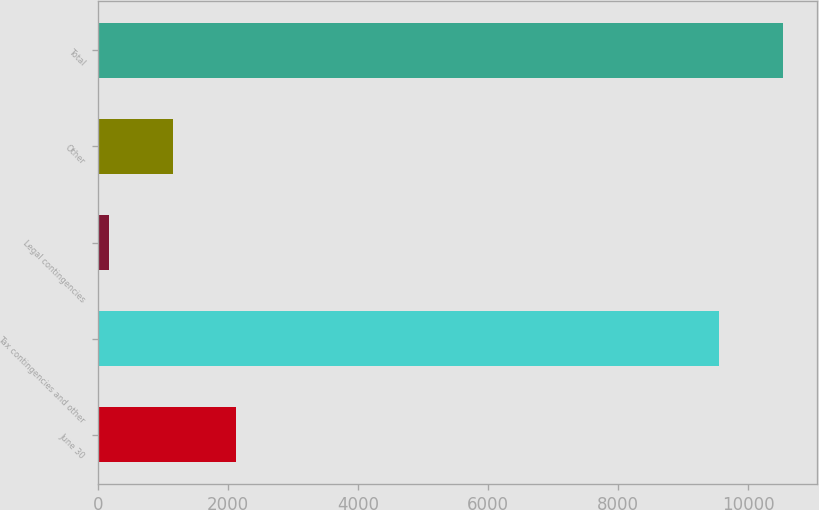Convert chart. <chart><loc_0><loc_0><loc_500><loc_500><bar_chart><fcel>June 30<fcel>Tax contingencies and other<fcel>Legal contingencies<fcel>Other<fcel>Total<nl><fcel>2129.6<fcel>9548<fcel>162<fcel>1145.8<fcel>10531.8<nl></chart> 